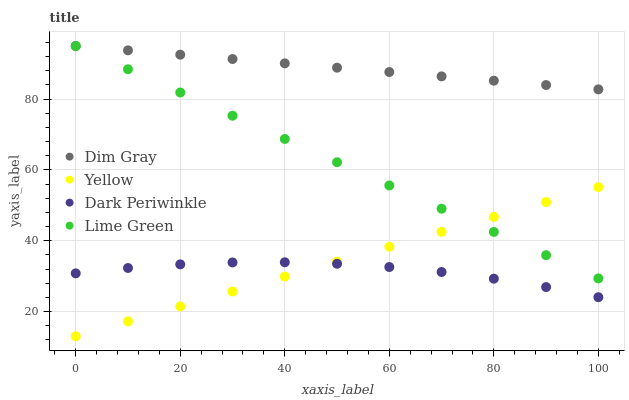Does Dark Periwinkle have the minimum area under the curve?
Answer yes or no. Yes. Does Dim Gray have the maximum area under the curve?
Answer yes or no. Yes. Does Lime Green have the minimum area under the curve?
Answer yes or no. No. Does Lime Green have the maximum area under the curve?
Answer yes or no. No. Is Yellow the smoothest?
Answer yes or no. Yes. Is Dark Periwinkle the roughest?
Answer yes or no. Yes. Is Lime Green the smoothest?
Answer yes or no. No. Is Lime Green the roughest?
Answer yes or no. No. Does Yellow have the lowest value?
Answer yes or no. Yes. Does Lime Green have the lowest value?
Answer yes or no. No. Does Lime Green have the highest value?
Answer yes or no. Yes. Does Dark Periwinkle have the highest value?
Answer yes or no. No. Is Dark Periwinkle less than Dim Gray?
Answer yes or no. Yes. Is Lime Green greater than Dark Periwinkle?
Answer yes or no. Yes. Does Lime Green intersect Yellow?
Answer yes or no. Yes. Is Lime Green less than Yellow?
Answer yes or no. No. Is Lime Green greater than Yellow?
Answer yes or no. No. Does Dark Periwinkle intersect Dim Gray?
Answer yes or no. No. 